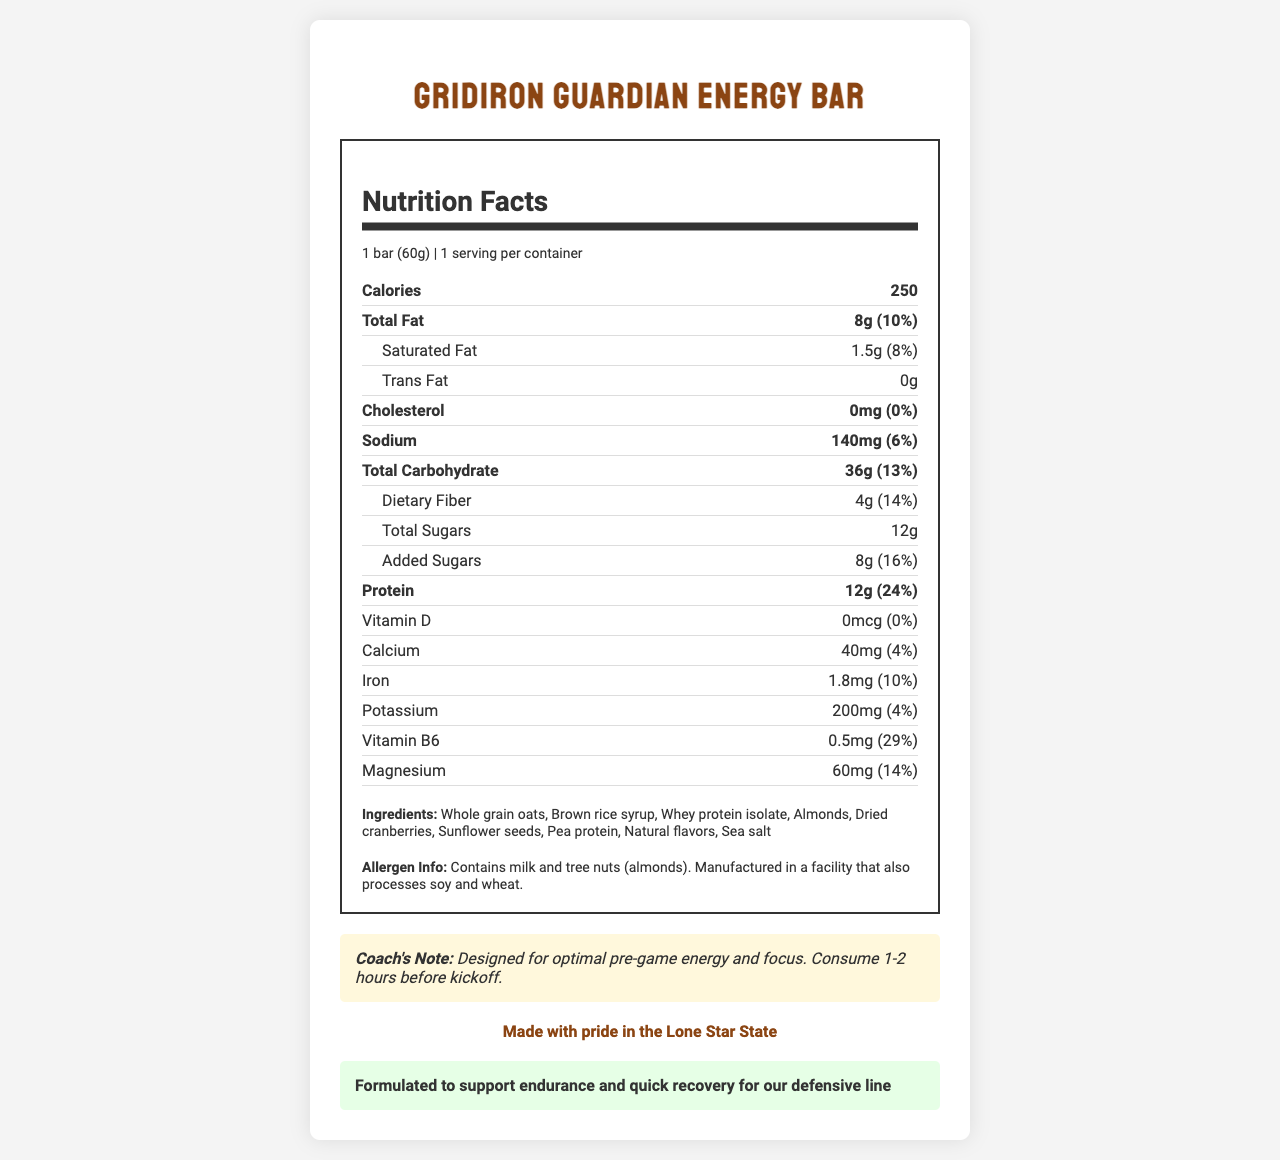what is the serving size for the Gridiron Guardian Energy Bar? The serving size is listed as "1 bar (60g)" on the Nutrition Facts label.
Answer: 1 bar (60g) how many calories does one serving of the energy bar contain? The Nutrition Facts label indicates that one serving contains 250 calories.
Answer: 250 calories what is the amount of protein in one energy bar, and what percentage of the daily value does it represent? The Nutrition Facts label shows that one bar contains 12g of protein, which represents 24% of the daily value.
Answer: 12g, 24% what are the main ingredients listed for the Gridiron Guardian Energy Bar? The ingredients are listed under "Ingredients" on the document.
Answer: Whole grain oats, Brown rice syrup, Whey protein isolate, Almonds, Dried cranberries, Sunflower seeds, Pea protein, Natural flavors, Sea salt what is the coach's recommendation for consuming the energy bar? The coach's note at the bottom of the document recommends consuming the bar 1-2 hours before kickoff.
Answer: Consume 1-2 hours before kickoff what is the total fat content of the energy bar and what is its daily value percentage? A. 6g, 8% B. 8g, 10% C. 10g, 12% The Nutrition Facts label states that the energy bar contains 8g of total fat, which is 10% of the daily value.
Answer: B how much sodium does one energy bar contain? A. 120mg B. 140mg C. 160mg D. 180mg The Nutrition Facts label specifies that the energy bar contains 140mg of sodium.
Answer: B does the Gridiron Guardian Energy Bar contain any trans fat? The Nutrition Facts label indicates that there is 0g of trans fat in the energy bar.
Answer: No is the energy bar made with pride in Texas? The document includes a "Texas Pride" section that states, "Made with pride in the Lone Star State."
Answer: Yes what is the main purpose of the Gridiron Guardian Energy Bar as indicated by the coach's note and the defensive boost label? The coach's note emphasizes it is designed for optimal pre-game energy and focus, while the defensive boost label indicates it supports endurance and quick recovery for the defensive line.
Answer: To provide optimal pre-game energy, focus, and support for endurance and quick recovery for the defensive line does the energy bar contain any Vitamin D? The Nutrition Facts label shows that the energy bar contains 0mcg of Vitamin D, which is 0% of the daily value.
Answer: No what is the total carbohydrate content and its daily value percentage for the Gridiron Guardian Energy Bar? The Nutrition Facts label indicates that the energy bar contains 36g of total carbohydrates, which is 13% of the daily value.
Answer: 36g, 13% how much iron is in the Gridiron Guardian Energy Bar, and what percentage of the daily value does it represent? The Nutrition Facts label shows that the energy bar contains 1.8mg of iron, which is 10% of the daily value.
Answer: 1.8mg, 10% what ingredient in the energy bar could be a potential allergen? The allergen information section states that the product contains milk and tree nuts (almonds).
Answer: Milk and tree nuts (almonds) what is the main idea of the document? The document includes a title, Nutrition Facts, ingredients, allergen info, coach's recommendation, Texas Pride highlight, and Defensive Boost feature. It aims to offer an energy bar that supports the needs of defensive players with specific nutrient contents and ingredients.
Answer: The document provides comprehensive nutritional information, ingredient details, and specific recommendations for a pre-game energy bar tailored for defensive players on a high school football team, emphasizing energy, focus, endurance, and quick recovery. what is the manufacturing process of the Gridiron Guardian Energy Bar? The document does not provide any information about the manufacturing process.
Answer: Not enough information 